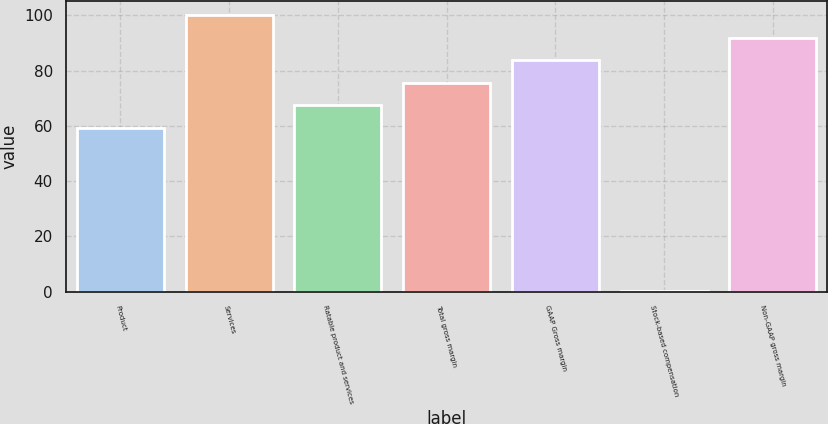Convert chart. <chart><loc_0><loc_0><loc_500><loc_500><bar_chart><fcel>Product<fcel>Services<fcel>Ratable product and services<fcel>Total gross margin<fcel>GAAP Gross margin<fcel>Stock-based compensation<fcel>Non-GAAP gross margin<nl><fcel>59.2<fcel>100.1<fcel>67.38<fcel>75.56<fcel>83.74<fcel>0.2<fcel>91.92<nl></chart> 